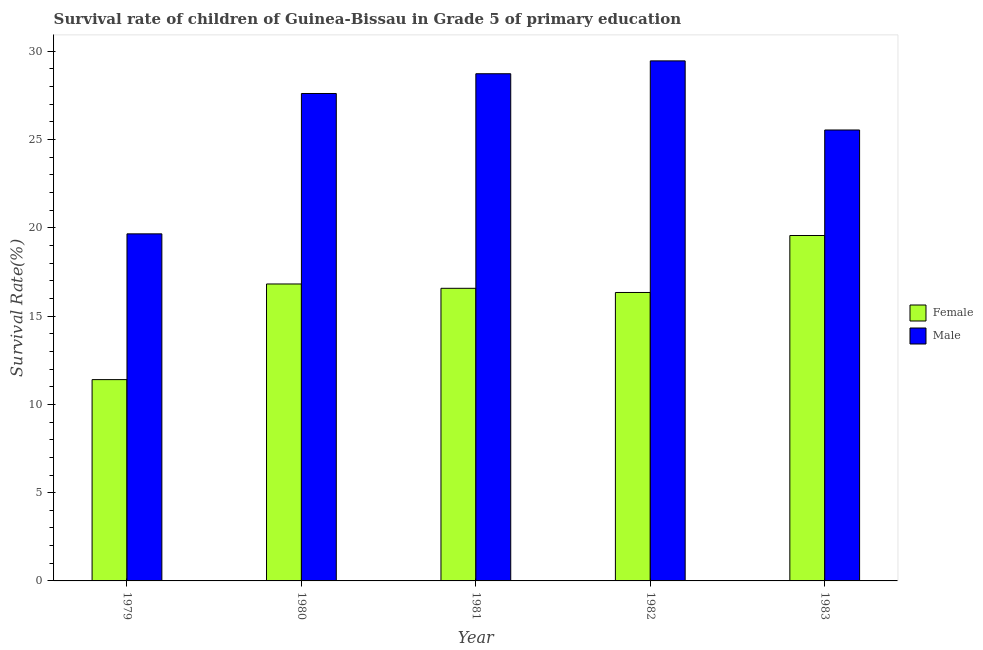How many different coloured bars are there?
Your response must be concise. 2. How many groups of bars are there?
Keep it short and to the point. 5. Are the number of bars on each tick of the X-axis equal?
Keep it short and to the point. Yes. How many bars are there on the 1st tick from the left?
Provide a short and direct response. 2. How many bars are there on the 2nd tick from the right?
Your response must be concise. 2. In how many cases, is the number of bars for a given year not equal to the number of legend labels?
Offer a very short reply. 0. What is the survival rate of male students in primary education in 1979?
Your response must be concise. 19.66. Across all years, what is the maximum survival rate of female students in primary education?
Provide a short and direct response. 19.57. Across all years, what is the minimum survival rate of female students in primary education?
Keep it short and to the point. 11.4. In which year was the survival rate of male students in primary education maximum?
Offer a very short reply. 1982. In which year was the survival rate of male students in primary education minimum?
Your response must be concise. 1979. What is the total survival rate of female students in primary education in the graph?
Make the answer very short. 80.71. What is the difference between the survival rate of male students in primary education in 1979 and that in 1980?
Your response must be concise. -7.95. What is the difference between the survival rate of female students in primary education in 1980 and the survival rate of male students in primary education in 1983?
Offer a very short reply. -2.75. What is the average survival rate of female students in primary education per year?
Your answer should be compact. 16.14. What is the ratio of the survival rate of female students in primary education in 1980 to that in 1981?
Provide a succinct answer. 1.01. Is the survival rate of female students in primary education in 1979 less than that in 1980?
Give a very brief answer. Yes. What is the difference between the highest and the second highest survival rate of male students in primary education?
Make the answer very short. 0.73. What is the difference between the highest and the lowest survival rate of male students in primary education?
Offer a very short reply. 9.8. In how many years, is the survival rate of female students in primary education greater than the average survival rate of female students in primary education taken over all years?
Your answer should be very brief. 4. Is the sum of the survival rate of male students in primary education in 1980 and 1983 greater than the maximum survival rate of female students in primary education across all years?
Offer a very short reply. Yes. How many bars are there?
Provide a succinct answer. 10. Are all the bars in the graph horizontal?
Give a very brief answer. No. How many years are there in the graph?
Offer a very short reply. 5. What is the difference between two consecutive major ticks on the Y-axis?
Provide a short and direct response. 5. Are the values on the major ticks of Y-axis written in scientific E-notation?
Your response must be concise. No. Does the graph contain grids?
Give a very brief answer. No. How many legend labels are there?
Your answer should be compact. 2. How are the legend labels stacked?
Offer a terse response. Vertical. What is the title of the graph?
Provide a succinct answer. Survival rate of children of Guinea-Bissau in Grade 5 of primary education. What is the label or title of the Y-axis?
Provide a short and direct response. Survival Rate(%). What is the Survival Rate(%) of Female in 1979?
Your response must be concise. 11.4. What is the Survival Rate(%) in Male in 1979?
Offer a very short reply. 19.66. What is the Survival Rate(%) of Female in 1980?
Keep it short and to the point. 16.82. What is the Survival Rate(%) in Male in 1980?
Your answer should be compact. 27.61. What is the Survival Rate(%) in Female in 1981?
Make the answer very short. 16.58. What is the Survival Rate(%) in Male in 1981?
Offer a terse response. 28.73. What is the Survival Rate(%) of Female in 1982?
Provide a short and direct response. 16.34. What is the Survival Rate(%) in Male in 1982?
Provide a short and direct response. 29.46. What is the Survival Rate(%) in Female in 1983?
Ensure brevity in your answer.  19.57. What is the Survival Rate(%) of Male in 1983?
Your response must be concise. 25.54. Across all years, what is the maximum Survival Rate(%) in Female?
Offer a terse response. 19.57. Across all years, what is the maximum Survival Rate(%) of Male?
Keep it short and to the point. 29.46. Across all years, what is the minimum Survival Rate(%) in Female?
Ensure brevity in your answer.  11.4. Across all years, what is the minimum Survival Rate(%) of Male?
Provide a short and direct response. 19.66. What is the total Survival Rate(%) in Female in the graph?
Offer a very short reply. 80.71. What is the total Survival Rate(%) of Male in the graph?
Your answer should be compact. 131.01. What is the difference between the Survival Rate(%) in Female in 1979 and that in 1980?
Ensure brevity in your answer.  -5.42. What is the difference between the Survival Rate(%) in Male in 1979 and that in 1980?
Offer a very short reply. -7.95. What is the difference between the Survival Rate(%) in Female in 1979 and that in 1981?
Provide a succinct answer. -5.17. What is the difference between the Survival Rate(%) of Male in 1979 and that in 1981?
Provide a succinct answer. -9.07. What is the difference between the Survival Rate(%) in Female in 1979 and that in 1982?
Provide a short and direct response. -4.94. What is the difference between the Survival Rate(%) of Male in 1979 and that in 1982?
Provide a short and direct response. -9.8. What is the difference between the Survival Rate(%) of Female in 1979 and that in 1983?
Make the answer very short. -8.16. What is the difference between the Survival Rate(%) of Male in 1979 and that in 1983?
Your answer should be very brief. -5.88. What is the difference between the Survival Rate(%) of Female in 1980 and that in 1981?
Your answer should be compact. 0.24. What is the difference between the Survival Rate(%) in Male in 1980 and that in 1981?
Ensure brevity in your answer.  -1.12. What is the difference between the Survival Rate(%) of Female in 1980 and that in 1982?
Provide a succinct answer. 0.48. What is the difference between the Survival Rate(%) of Male in 1980 and that in 1982?
Ensure brevity in your answer.  -1.85. What is the difference between the Survival Rate(%) of Female in 1980 and that in 1983?
Offer a very short reply. -2.75. What is the difference between the Survival Rate(%) in Male in 1980 and that in 1983?
Your answer should be compact. 2.07. What is the difference between the Survival Rate(%) in Female in 1981 and that in 1982?
Your answer should be compact. 0.24. What is the difference between the Survival Rate(%) in Male in 1981 and that in 1982?
Make the answer very short. -0.73. What is the difference between the Survival Rate(%) in Female in 1981 and that in 1983?
Provide a short and direct response. -2.99. What is the difference between the Survival Rate(%) in Male in 1981 and that in 1983?
Offer a terse response. 3.19. What is the difference between the Survival Rate(%) of Female in 1982 and that in 1983?
Your answer should be compact. -3.23. What is the difference between the Survival Rate(%) in Male in 1982 and that in 1983?
Your response must be concise. 3.92. What is the difference between the Survival Rate(%) in Female in 1979 and the Survival Rate(%) in Male in 1980?
Make the answer very short. -16.21. What is the difference between the Survival Rate(%) of Female in 1979 and the Survival Rate(%) of Male in 1981?
Provide a succinct answer. -17.33. What is the difference between the Survival Rate(%) in Female in 1979 and the Survival Rate(%) in Male in 1982?
Give a very brief answer. -18.06. What is the difference between the Survival Rate(%) in Female in 1979 and the Survival Rate(%) in Male in 1983?
Make the answer very short. -14.14. What is the difference between the Survival Rate(%) of Female in 1980 and the Survival Rate(%) of Male in 1981?
Your answer should be compact. -11.91. What is the difference between the Survival Rate(%) in Female in 1980 and the Survival Rate(%) in Male in 1982?
Make the answer very short. -12.64. What is the difference between the Survival Rate(%) of Female in 1980 and the Survival Rate(%) of Male in 1983?
Your answer should be compact. -8.72. What is the difference between the Survival Rate(%) in Female in 1981 and the Survival Rate(%) in Male in 1982?
Offer a very short reply. -12.88. What is the difference between the Survival Rate(%) of Female in 1981 and the Survival Rate(%) of Male in 1983?
Your answer should be very brief. -8.97. What is the difference between the Survival Rate(%) of Female in 1982 and the Survival Rate(%) of Male in 1983?
Provide a succinct answer. -9.2. What is the average Survival Rate(%) of Female per year?
Your answer should be compact. 16.14. What is the average Survival Rate(%) of Male per year?
Give a very brief answer. 26.2. In the year 1979, what is the difference between the Survival Rate(%) in Female and Survival Rate(%) in Male?
Provide a succinct answer. -8.26. In the year 1980, what is the difference between the Survival Rate(%) of Female and Survival Rate(%) of Male?
Provide a succinct answer. -10.79. In the year 1981, what is the difference between the Survival Rate(%) in Female and Survival Rate(%) in Male?
Offer a very short reply. -12.15. In the year 1982, what is the difference between the Survival Rate(%) in Female and Survival Rate(%) in Male?
Your answer should be very brief. -13.12. In the year 1983, what is the difference between the Survival Rate(%) of Female and Survival Rate(%) of Male?
Offer a very short reply. -5.98. What is the ratio of the Survival Rate(%) of Female in 1979 to that in 1980?
Provide a short and direct response. 0.68. What is the ratio of the Survival Rate(%) in Male in 1979 to that in 1980?
Offer a terse response. 0.71. What is the ratio of the Survival Rate(%) in Female in 1979 to that in 1981?
Your answer should be very brief. 0.69. What is the ratio of the Survival Rate(%) of Male in 1979 to that in 1981?
Offer a terse response. 0.68. What is the ratio of the Survival Rate(%) of Female in 1979 to that in 1982?
Make the answer very short. 0.7. What is the ratio of the Survival Rate(%) in Male in 1979 to that in 1982?
Your response must be concise. 0.67. What is the ratio of the Survival Rate(%) in Female in 1979 to that in 1983?
Make the answer very short. 0.58. What is the ratio of the Survival Rate(%) in Male in 1979 to that in 1983?
Keep it short and to the point. 0.77. What is the ratio of the Survival Rate(%) of Female in 1980 to that in 1981?
Make the answer very short. 1.01. What is the ratio of the Survival Rate(%) of Male in 1980 to that in 1981?
Your response must be concise. 0.96. What is the ratio of the Survival Rate(%) in Female in 1980 to that in 1982?
Make the answer very short. 1.03. What is the ratio of the Survival Rate(%) of Male in 1980 to that in 1982?
Provide a short and direct response. 0.94. What is the ratio of the Survival Rate(%) in Female in 1980 to that in 1983?
Your answer should be compact. 0.86. What is the ratio of the Survival Rate(%) in Male in 1980 to that in 1983?
Keep it short and to the point. 1.08. What is the ratio of the Survival Rate(%) in Female in 1981 to that in 1982?
Give a very brief answer. 1.01. What is the ratio of the Survival Rate(%) of Male in 1981 to that in 1982?
Provide a short and direct response. 0.98. What is the ratio of the Survival Rate(%) of Female in 1981 to that in 1983?
Your answer should be compact. 0.85. What is the ratio of the Survival Rate(%) in Male in 1981 to that in 1983?
Ensure brevity in your answer.  1.12. What is the ratio of the Survival Rate(%) in Female in 1982 to that in 1983?
Ensure brevity in your answer.  0.84. What is the ratio of the Survival Rate(%) of Male in 1982 to that in 1983?
Make the answer very short. 1.15. What is the difference between the highest and the second highest Survival Rate(%) of Female?
Provide a short and direct response. 2.75. What is the difference between the highest and the second highest Survival Rate(%) of Male?
Your answer should be compact. 0.73. What is the difference between the highest and the lowest Survival Rate(%) in Female?
Provide a short and direct response. 8.16. What is the difference between the highest and the lowest Survival Rate(%) of Male?
Offer a terse response. 9.8. 